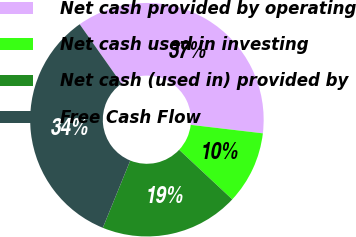<chart> <loc_0><loc_0><loc_500><loc_500><pie_chart><fcel>Net cash provided by operating<fcel>Net cash used in investing<fcel>Net cash (used in) provided by<fcel>Free Cash Flow<nl><fcel>36.63%<fcel>10.09%<fcel>19.21%<fcel>34.07%<nl></chart> 